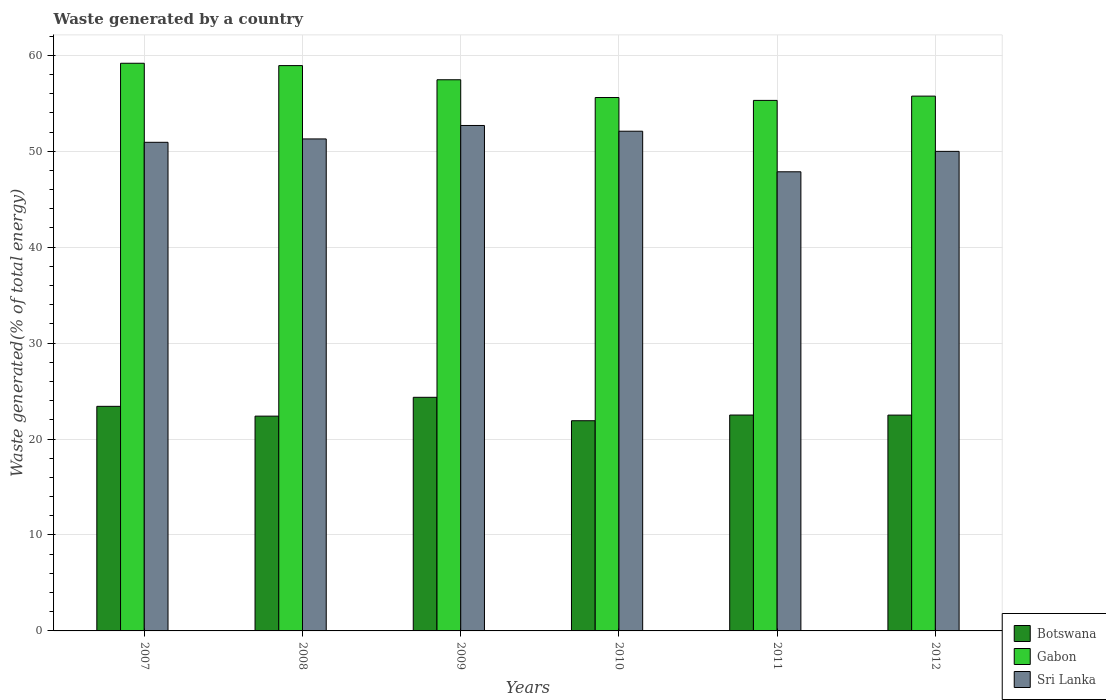How many different coloured bars are there?
Offer a terse response. 3. How many groups of bars are there?
Provide a short and direct response. 6. Are the number of bars per tick equal to the number of legend labels?
Offer a terse response. Yes. Are the number of bars on each tick of the X-axis equal?
Offer a very short reply. Yes. How many bars are there on the 4th tick from the left?
Offer a very short reply. 3. In how many cases, is the number of bars for a given year not equal to the number of legend labels?
Give a very brief answer. 0. What is the total waste generated in Sri Lanka in 2009?
Offer a very short reply. 52.68. Across all years, what is the maximum total waste generated in Gabon?
Provide a short and direct response. 59.17. Across all years, what is the minimum total waste generated in Sri Lanka?
Offer a very short reply. 47.86. In which year was the total waste generated in Sri Lanka maximum?
Provide a short and direct response. 2009. In which year was the total waste generated in Botswana minimum?
Your answer should be very brief. 2010. What is the total total waste generated in Botswana in the graph?
Provide a short and direct response. 137.05. What is the difference between the total waste generated in Botswana in 2009 and that in 2012?
Your response must be concise. 1.86. What is the difference between the total waste generated in Botswana in 2008 and the total waste generated in Sri Lanka in 2010?
Make the answer very short. -29.7. What is the average total waste generated in Gabon per year?
Make the answer very short. 57.03. In the year 2009, what is the difference between the total waste generated in Botswana and total waste generated in Gabon?
Offer a very short reply. -33.1. In how many years, is the total waste generated in Sri Lanka greater than 30 %?
Offer a terse response. 6. What is the ratio of the total waste generated in Botswana in 2008 to that in 2012?
Give a very brief answer. 1. Is the total waste generated in Sri Lanka in 2007 less than that in 2012?
Give a very brief answer. No. What is the difference between the highest and the second highest total waste generated in Botswana?
Your answer should be very brief. 0.94. What is the difference between the highest and the lowest total waste generated in Gabon?
Keep it short and to the point. 3.87. In how many years, is the total waste generated in Botswana greater than the average total waste generated in Botswana taken over all years?
Provide a short and direct response. 2. Is the sum of the total waste generated in Gabon in 2010 and 2012 greater than the maximum total waste generated in Sri Lanka across all years?
Give a very brief answer. Yes. What does the 1st bar from the left in 2011 represents?
Your response must be concise. Botswana. What does the 2nd bar from the right in 2012 represents?
Ensure brevity in your answer.  Gabon. Is it the case that in every year, the sum of the total waste generated in Gabon and total waste generated in Botswana is greater than the total waste generated in Sri Lanka?
Offer a terse response. Yes. How many bars are there?
Your answer should be compact. 18. Are all the bars in the graph horizontal?
Ensure brevity in your answer.  No. Does the graph contain any zero values?
Ensure brevity in your answer.  No. Does the graph contain grids?
Provide a succinct answer. Yes. How are the legend labels stacked?
Make the answer very short. Vertical. What is the title of the graph?
Your response must be concise. Waste generated by a country. What is the label or title of the Y-axis?
Your response must be concise. Waste generated(% of total energy). What is the Waste generated(% of total energy) of Botswana in 2007?
Make the answer very short. 23.41. What is the Waste generated(% of total energy) of Gabon in 2007?
Your answer should be compact. 59.17. What is the Waste generated(% of total energy) of Sri Lanka in 2007?
Your answer should be compact. 50.93. What is the Waste generated(% of total energy) in Botswana in 2008?
Provide a short and direct response. 22.39. What is the Waste generated(% of total energy) of Gabon in 2008?
Offer a very short reply. 58.93. What is the Waste generated(% of total energy) of Sri Lanka in 2008?
Give a very brief answer. 51.28. What is the Waste generated(% of total energy) in Botswana in 2009?
Offer a terse response. 24.35. What is the Waste generated(% of total energy) in Gabon in 2009?
Offer a terse response. 57.45. What is the Waste generated(% of total energy) in Sri Lanka in 2009?
Ensure brevity in your answer.  52.68. What is the Waste generated(% of total energy) of Botswana in 2010?
Give a very brief answer. 21.91. What is the Waste generated(% of total energy) in Gabon in 2010?
Provide a short and direct response. 55.6. What is the Waste generated(% of total energy) of Sri Lanka in 2010?
Your response must be concise. 52.09. What is the Waste generated(% of total energy) of Botswana in 2011?
Offer a terse response. 22.5. What is the Waste generated(% of total energy) in Gabon in 2011?
Offer a very short reply. 55.3. What is the Waste generated(% of total energy) of Sri Lanka in 2011?
Make the answer very short. 47.86. What is the Waste generated(% of total energy) in Botswana in 2012?
Ensure brevity in your answer.  22.5. What is the Waste generated(% of total energy) of Gabon in 2012?
Your response must be concise. 55.74. What is the Waste generated(% of total energy) in Sri Lanka in 2012?
Make the answer very short. 49.99. Across all years, what is the maximum Waste generated(% of total energy) in Botswana?
Keep it short and to the point. 24.35. Across all years, what is the maximum Waste generated(% of total energy) in Gabon?
Give a very brief answer. 59.17. Across all years, what is the maximum Waste generated(% of total energy) of Sri Lanka?
Your response must be concise. 52.68. Across all years, what is the minimum Waste generated(% of total energy) of Botswana?
Offer a very short reply. 21.91. Across all years, what is the minimum Waste generated(% of total energy) of Gabon?
Give a very brief answer. 55.3. Across all years, what is the minimum Waste generated(% of total energy) in Sri Lanka?
Keep it short and to the point. 47.86. What is the total Waste generated(% of total energy) of Botswana in the graph?
Provide a succinct answer. 137.05. What is the total Waste generated(% of total energy) in Gabon in the graph?
Provide a succinct answer. 342.18. What is the total Waste generated(% of total energy) of Sri Lanka in the graph?
Ensure brevity in your answer.  304.82. What is the difference between the Waste generated(% of total energy) in Botswana in 2007 and that in 2008?
Give a very brief answer. 1.02. What is the difference between the Waste generated(% of total energy) in Gabon in 2007 and that in 2008?
Your answer should be very brief. 0.24. What is the difference between the Waste generated(% of total energy) of Sri Lanka in 2007 and that in 2008?
Ensure brevity in your answer.  -0.35. What is the difference between the Waste generated(% of total energy) in Botswana in 2007 and that in 2009?
Offer a very short reply. -0.94. What is the difference between the Waste generated(% of total energy) of Gabon in 2007 and that in 2009?
Your response must be concise. 1.72. What is the difference between the Waste generated(% of total energy) of Sri Lanka in 2007 and that in 2009?
Provide a succinct answer. -1.75. What is the difference between the Waste generated(% of total energy) of Botswana in 2007 and that in 2010?
Provide a succinct answer. 1.5. What is the difference between the Waste generated(% of total energy) of Gabon in 2007 and that in 2010?
Ensure brevity in your answer.  3.57. What is the difference between the Waste generated(% of total energy) of Sri Lanka in 2007 and that in 2010?
Provide a succinct answer. -1.16. What is the difference between the Waste generated(% of total energy) of Botswana in 2007 and that in 2011?
Keep it short and to the point. 0.91. What is the difference between the Waste generated(% of total energy) of Gabon in 2007 and that in 2011?
Your answer should be compact. 3.87. What is the difference between the Waste generated(% of total energy) in Sri Lanka in 2007 and that in 2011?
Provide a short and direct response. 3.07. What is the difference between the Waste generated(% of total energy) of Botswana in 2007 and that in 2012?
Your answer should be compact. 0.91. What is the difference between the Waste generated(% of total energy) of Gabon in 2007 and that in 2012?
Provide a succinct answer. 3.43. What is the difference between the Waste generated(% of total energy) of Sri Lanka in 2007 and that in 2012?
Your response must be concise. 0.94. What is the difference between the Waste generated(% of total energy) of Botswana in 2008 and that in 2009?
Provide a short and direct response. -1.96. What is the difference between the Waste generated(% of total energy) in Gabon in 2008 and that in 2009?
Give a very brief answer. 1.48. What is the difference between the Waste generated(% of total energy) in Sri Lanka in 2008 and that in 2009?
Your response must be concise. -1.4. What is the difference between the Waste generated(% of total energy) of Botswana in 2008 and that in 2010?
Make the answer very short. 0.48. What is the difference between the Waste generated(% of total energy) of Gabon in 2008 and that in 2010?
Provide a short and direct response. 3.33. What is the difference between the Waste generated(% of total energy) in Sri Lanka in 2008 and that in 2010?
Your answer should be very brief. -0.8. What is the difference between the Waste generated(% of total energy) of Botswana in 2008 and that in 2011?
Give a very brief answer. -0.11. What is the difference between the Waste generated(% of total energy) of Gabon in 2008 and that in 2011?
Keep it short and to the point. 3.63. What is the difference between the Waste generated(% of total energy) in Sri Lanka in 2008 and that in 2011?
Your answer should be compact. 3.43. What is the difference between the Waste generated(% of total energy) of Botswana in 2008 and that in 2012?
Ensure brevity in your answer.  -0.11. What is the difference between the Waste generated(% of total energy) in Gabon in 2008 and that in 2012?
Provide a short and direct response. 3.18. What is the difference between the Waste generated(% of total energy) of Sri Lanka in 2008 and that in 2012?
Your answer should be compact. 1.3. What is the difference between the Waste generated(% of total energy) of Botswana in 2009 and that in 2010?
Your answer should be very brief. 2.44. What is the difference between the Waste generated(% of total energy) of Gabon in 2009 and that in 2010?
Make the answer very short. 1.85. What is the difference between the Waste generated(% of total energy) of Sri Lanka in 2009 and that in 2010?
Make the answer very short. 0.6. What is the difference between the Waste generated(% of total energy) in Botswana in 2009 and that in 2011?
Keep it short and to the point. 1.85. What is the difference between the Waste generated(% of total energy) of Gabon in 2009 and that in 2011?
Offer a very short reply. 2.15. What is the difference between the Waste generated(% of total energy) of Sri Lanka in 2009 and that in 2011?
Offer a terse response. 4.83. What is the difference between the Waste generated(% of total energy) of Botswana in 2009 and that in 2012?
Provide a short and direct response. 1.86. What is the difference between the Waste generated(% of total energy) in Gabon in 2009 and that in 2012?
Your answer should be very brief. 1.71. What is the difference between the Waste generated(% of total energy) of Sri Lanka in 2009 and that in 2012?
Provide a short and direct response. 2.7. What is the difference between the Waste generated(% of total energy) of Botswana in 2010 and that in 2011?
Ensure brevity in your answer.  -0.59. What is the difference between the Waste generated(% of total energy) of Gabon in 2010 and that in 2011?
Give a very brief answer. 0.3. What is the difference between the Waste generated(% of total energy) of Sri Lanka in 2010 and that in 2011?
Make the answer very short. 4.23. What is the difference between the Waste generated(% of total energy) of Botswana in 2010 and that in 2012?
Keep it short and to the point. -0.59. What is the difference between the Waste generated(% of total energy) in Gabon in 2010 and that in 2012?
Provide a short and direct response. -0.15. What is the difference between the Waste generated(% of total energy) of Sri Lanka in 2010 and that in 2012?
Your answer should be compact. 2.1. What is the difference between the Waste generated(% of total energy) of Botswana in 2011 and that in 2012?
Your response must be concise. 0.01. What is the difference between the Waste generated(% of total energy) in Gabon in 2011 and that in 2012?
Offer a very short reply. -0.45. What is the difference between the Waste generated(% of total energy) of Sri Lanka in 2011 and that in 2012?
Make the answer very short. -2.13. What is the difference between the Waste generated(% of total energy) of Botswana in 2007 and the Waste generated(% of total energy) of Gabon in 2008?
Your answer should be compact. -35.52. What is the difference between the Waste generated(% of total energy) of Botswana in 2007 and the Waste generated(% of total energy) of Sri Lanka in 2008?
Your answer should be compact. -27.87. What is the difference between the Waste generated(% of total energy) in Gabon in 2007 and the Waste generated(% of total energy) in Sri Lanka in 2008?
Ensure brevity in your answer.  7.89. What is the difference between the Waste generated(% of total energy) in Botswana in 2007 and the Waste generated(% of total energy) in Gabon in 2009?
Offer a very short reply. -34.04. What is the difference between the Waste generated(% of total energy) of Botswana in 2007 and the Waste generated(% of total energy) of Sri Lanka in 2009?
Give a very brief answer. -29.28. What is the difference between the Waste generated(% of total energy) in Gabon in 2007 and the Waste generated(% of total energy) in Sri Lanka in 2009?
Keep it short and to the point. 6.48. What is the difference between the Waste generated(% of total energy) in Botswana in 2007 and the Waste generated(% of total energy) in Gabon in 2010?
Your answer should be very brief. -32.19. What is the difference between the Waste generated(% of total energy) of Botswana in 2007 and the Waste generated(% of total energy) of Sri Lanka in 2010?
Provide a short and direct response. -28.68. What is the difference between the Waste generated(% of total energy) of Gabon in 2007 and the Waste generated(% of total energy) of Sri Lanka in 2010?
Your answer should be very brief. 7.08. What is the difference between the Waste generated(% of total energy) in Botswana in 2007 and the Waste generated(% of total energy) in Gabon in 2011?
Offer a terse response. -31.89. What is the difference between the Waste generated(% of total energy) of Botswana in 2007 and the Waste generated(% of total energy) of Sri Lanka in 2011?
Provide a succinct answer. -24.45. What is the difference between the Waste generated(% of total energy) in Gabon in 2007 and the Waste generated(% of total energy) in Sri Lanka in 2011?
Your response must be concise. 11.31. What is the difference between the Waste generated(% of total energy) of Botswana in 2007 and the Waste generated(% of total energy) of Gabon in 2012?
Give a very brief answer. -32.33. What is the difference between the Waste generated(% of total energy) in Botswana in 2007 and the Waste generated(% of total energy) in Sri Lanka in 2012?
Your answer should be very brief. -26.58. What is the difference between the Waste generated(% of total energy) in Gabon in 2007 and the Waste generated(% of total energy) in Sri Lanka in 2012?
Your answer should be compact. 9.18. What is the difference between the Waste generated(% of total energy) in Botswana in 2008 and the Waste generated(% of total energy) in Gabon in 2009?
Your response must be concise. -35.06. What is the difference between the Waste generated(% of total energy) in Botswana in 2008 and the Waste generated(% of total energy) in Sri Lanka in 2009?
Provide a short and direct response. -30.3. What is the difference between the Waste generated(% of total energy) in Gabon in 2008 and the Waste generated(% of total energy) in Sri Lanka in 2009?
Your answer should be very brief. 6.24. What is the difference between the Waste generated(% of total energy) of Botswana in 2008 and the Waste generated(% of total energy) of Gabon in 2010?
Give a very brief answer. -33.21. What is the difference between the Waste generated(% of total energy) in Botswana in 2008 and the Waste generated(% of total energy) in Sri Lanka in 2010?
Make the answer very short. -29.7. What is the difference between the Waste generated(% of total energy) in Gabon in 2008 and the Waste generated(% of total energy) in Sri Lanka in 2010?
Provide a short and direct response. 6.84. What is the difference between the Waste generated(% of total energy) in Botswana in 2008 and the Waste generated(% of total energy) in Gabon in 2011?
Your answer should be very brief. -32.91. What is the difference between the Waste generated(% of total energy) of Botswana in 2008 and the Waste generated(% of total energy) of Sri Lanka in 2011?
Your response must be concise. -25.47. What is the difference between the Waste generated(% of total energy) in Gabon in 2008 and the Waste generated(% of total energy) in Sri Lanka in 2011?
Ensure brevity in your answer.  11.07. What is the difference between the Waste generated(% of total energy) in Botswana in 2008 and the Waste generated(% of total energy) in Gabon in 2012?
Give a very brief answer. -33.36. What is the difference between the Waste generated(% of total energy) of Botswana in 2008 and the Waste generated(% of total energy) of Sri Lanka in 2012?
Provide a short and direct response. -27.6. What is the difference between the Waste generated(% of total energy) of Gabon in 2008 and the Waste generated(% of total energy) of Sri Lanka in 2012?
Offer a very short reply. 8.94. What is the difference between the Waste generated(% of total energy) of Botswana in 2009 and the Waste generated(% of total energy) of Gabon in 2010?
Ensure brevity in your answer.  -31.25. What is the difference between the Waste generated(% of total energy) in Botswana in 2009 and the Waste generated(% of total energy) in Sri Lanka in 2010?
Your answer should be very brief. -27.74. What is the difference between the Waste generated(% of total energy) in Gabon in 2009 and the Waste generated(% of total energy) in Sri Lanka in 2010?
Your answer should be very brief. 5.36. What is the difference between the Waste generated(% of total energy) in Botswana in 2009 and the Waste generated(% of total energy) in Gabon in 2011?
Provide a short and direct response. -30.95. What is the difference between the Waste generated(% of total energy) of Botswana in 2009 and the Waste generated(% of total energy) of Sri Lanka in 2011?
Ensure brevity in your answer.  -23.51. What is the difference between the Waste generated(% of total energy) in Gabon in 2009 and the Waste generated(% of total energy) in Sri Lanka in 2011?
Keep it short and to the point. 9.59. What is the difference between the Waste generated(% of total energy) of Botswana in 2009 and the Waste generated(% of total energy) of Gabon in 2012?
Offer a very short reply. -31.39. What is the difference between the Waste generated(% of total energy) in Botswana in 2009 and the Waste generated(% of total energy) in Sri Lanka in 2012?
Give a very brief answer. -25.63. What is the difference between the Waste generated(% of total energy) in Gabon in 2009 and the Waste generated(% of total energy) in Sri Lanka in 2012?
Provide a succinct answer. 7.46. What is the difference between the Waste generated(% of total energy) in Botswana in 2010 and the Waste generated(% of total energy) in Gabon in 2011?
Ensure brevity in your answer.  -33.39. What is the difference between the Waste generated(% of total energy) of Botswana in 2010 and the Waste generated(% of total energy) of Sri Lanka in 2011?
Offer a terse response. -25.95. What is the difference between the Waste generated(% of total energy) of Gabon in 2010 and the Waste generated(% of total energy) of Sri Lanka in 2011?
Your answer should be very brief. 7.74. What is the difference between the Waste generated(% of total energy) in Botswana in 2010 and the Waste generated(% of total energy) in Gabon in 2012?
Ensure brevity in your answer.  -33.83. What is the difference between the Waste generated(% of total energy) of Botswana in 2010 and the Waste generated(% of total energy) of Sri Lanka in 2012?
Offer a terse response. -28.08. What is the difference between the Waste generated(% of total energy) of Gabon in 2010 and the Waste generated(% of total energy) of Sri Lanka in 2012?
Your response must be concise. 5.61. What is the difference between the Waste generated(% of total energy) of Botswana in 2011 and the Waste generated(% of total energy) of Gabon in 2012?
Keep it short and to the point. -33.24. What is the difference between the Waste generated(% of total energy) in Botswana in 2011 and the Waste generated(% of total energy) in Sri Lanka in 2012?
Provide a succinct answer. -27.48. What is the difference between the Waste generated(% of total energy) of Gabon in 2011 and the Waste generated(% of total energy) of Sri Lanka in 2012?
Your response must be concise. 5.31. What is the average Waste generated(% of total energy) in Botswana per year?
Your response must be concise. 22.84. What is the average Waste generated(% of total energy) in Gabon per year?
Your answer should be very brief. 57.03. What is the average Waste generated(% of total energy) of Sri Lanka per year?
Ensure brevity in your answer.  50.8. In the year 2007, what is the difference between the Waste generated(% of total energy) in Botswana and Waste generated(% of total energy) in Gabon?
Offer a very short reply. -35.76. In the year 2007, what is the difference between the Waste generated(% of total energy) of Botswana and Waste generated(% of total energy) of Sri Lanka?
Make the answer very short. -27.52. In the year 2007, what is the difference between the Waste generated(% of total energy) of Gabon and Waste generated(% of total energy) of Sri Lanka?
Provide a short and direct response. 8.24. In the year 2008, what is the difference between the Waste generated(% of total energy) in Botswana and Waste generated(% of total energy) in Gabon?
Your answer should be very brief. -36.54. In the year 2008, what is the difference between the Waste generated(% of total energy) in Botswana and Waste generated(% of total energy) in Sri Lanka?
Make the answer very short. -28.89. In the year 2008, what is the difference between the Waste generated(% of total energy) in Gabon and Waste generated(% of total energy) in Sri Lanka?
Keep it short and to the point. 7.64. In the year 2009, what is the difference between the Waste generated(% of total energy) of Botswana and Waste generated(% of total energy) of Gabon?
Provide a succinct answer. -33.1. In the year 2009, what is the difference between the Waste generated(% of total energy) in Botswana and Waste generated(% of total energy) in Sri Lanka?
Provide a short and direct response. -28.33. In the year 2009, what is the difference between the Waste generated(% of total energy) of Gabon and Waste generated(% of total energy) of Sri Lanka?
Offer a very short reply. 4.76. In the year 2010, what is the difference between the Waste generated(% of total energy) of Botswana and Waste generated(% of total energy) of Gabon?
Ensure brevity in your answer.  -33.69. In the year 2010, what is the difference between the Waste generated(% of total energy) in Botswana and Waste generated(% of total energy) in Sri Lanka?
Your response must be concise. -30.18. In the year 2010, what is the difference between the Waste generated(% of total energy) of Gabon and Waste generated(% of total energy) of Sri Lanka?
Your response must be concise. 3.51. In the year 2011, what is the difference between the Waste generated(% of total energy) in Botswana and Waste generated(% of total energy) in Gabon?
Offer a terse response. -32.8. In the year 2011, what is the difference between the Waste generated(% of total energy) in Botswana and Waste generated(% of total energy) in Sri Lanka?
Your answer should be very brief. -25.36. In the year 2011, what is the difference between the Waste generated(% of total energy) in Gabon and Waste generated(% of total energy) in Sri Lanka?
Your response must be concise. 7.44. In the year 2012, what is the difference between the Waste generated(% of total energy) of Botswana and Waste generated(% of total energy) of Gabon?
Make the answer very short. -33.25. In the year 2012, what is the difference between the Waste generated(% of total energy) of Botswana and Waste generated(% of total energy) of Sri Lanka?
Keep it short and to the point. -27.49. In the year 2012, what is the difference between the Waste generated(% of total energy) of Gabon and Waste generated(% of total energy) of Sri Lanka?
Offer a terse response. 5.76. What is the ratio of the Waste generated(% of total energy) of Botswana in 2007 to that in 2008?
Provide a short and direct response. 1.05. What is the ratio of the Waste generated(% of total energy) in Gabon in 2007 to that in 2008?
Ensure brevity in your answer.  1. What is the ratio of the Waste generated(% of total energy) of Sri Lanka in 2007 to that in 2008?
Your answer should be compact. 0.99. What is the ratio of the Waste generated(% of total energy) of Botswana in 2007 to that in 2009?
Offer a terse response. 0.96. What is the ratio of the Waste generated(% of total energy) of Gabon in 2007 to that in 2009?
Your answer should be very brief. 1.03. What is the ratio of the Waste generated(% of total energy) of Sri Lanka in 2007 to that in 2009?
Offer a terse response. 0.97. What is the ratio of the Waste generated(% of total energy) of Botswana in 2007 to that in 2010?
Keep it short and to the point. 1.07. What is the ratio of the Waste generated(% of total energy) of Gabon in 2007 to that in 2010?
Ensure brevity in your answer.  1.06. What is the ratio of the Waste generated(% of total energy) in Sri Lanka in 2007 to that in 2010?
Your answer should be compact. 0.98. What is the ratio of the Waste generated(% of total energy) of Botswana in 2007 to that in 2011?
Give a very brief answer. 1.04. What is the ratio of the Waste generated(% of total energy) in Gabon in 2007 to that in 2011?
Make the answer very short. 1.07. What is the ratio of the Waste generated(% of total energy) of Sri Lanka in 2007 to that in 2011?
Your answer should be very brief. 1.06. What is the ratio of the Waste generated(% of total energy) in Botswana in 2007 to that in 2012?
Offer a very short reply. 1.04. What is the ratio of the Waste generated(% of total energy) of Gabon in 2007 to that in 2012?
Offer a terse response. 1.06. What is the ratio of the Waste generated(% of total energy) in Sri Lanka in 2007 to that in 2012?
Provide a short and direct response. 1.02. What is the ratio of the Waste generated(% of total energy) of Botswana in 2008 to that in 2009?
Offer a terse response. 0.92. What is the ratio of the Waste generated(% of total energy) in Gabon in 2008 to that in 2009?
Your answer should be very brief. 1.03. What is the ratio of the Waste generated(% of total energy) of Sri Lanka in 2008 to that in 2009?
Your answer should be compact. 0.97. What is the ratio of the Waste generated(% of total energy) in Botswana in 2008 to that in 2010?
Provide a succinct answer. 1.02. What is the ratio of the Waste generated(% of total energy) of Gabon in 2008 to that in 2010?
Your answer should be compact. 1.06. What is the ratio of the Waste generated(% of total energy) of Sri Lanka in 2008 to that in 2010?
Make the answer very short. 0.98. What is the ratio of the Waste generated(% of total energy) in Gabon in 2008 to that in 2011?
Keep it short and to the point. 1.07. What is the ratio of the Waste generated(% of total energy) of Sri Lanka in 2008 to that in 2011?
Provide a short and direct response. 1.07. What is the ratio of the Waste generated(% of total energy) in Botswana in 2008 to that in 2012?
Keep it short and to the point. 1. What is the ratio of the Waste generated(% of total energy) of Gabon in 2008 to that in 2012?
Offer a terse response. 1.06. What is the ratio of the Waste generated(% of total energy) in Sri Lanka in 2008 to that in 2012?
Ensure brevity in your answer.  1.03. What is the ratio of the Waste generated(% of total energy) of Botswana in 2009 to that in 2010?
Offer a very short reply. 1.11. What is the ratio of the Waste generated(% of total energy) of Sri Lanka in 2009 to that in 2010?
Your answer should be compact. 1.01. What is the ratio of the Waste generated(% of total energy) of Botswana in 2009 to that in 2011?
Offer a very short reply. 1.08. What is the ratio of the Waste generated(% of total energy) of Gabon in 2009 to that in 2011?
Provide a succinct answer. 1.04. What is the ratio of the Waste generated(% of total energy) in Sri Lanka in 2009 to that in 2011?
Give a very brief answer. 1.1. What is the ratio of the Waste generated(% of total energy) of Botswana in 2009 to that in 2012?
Offer a very short reply. 1.08. What is the ratio of the Waste generated(% of total energy) of Gabon in 2009 to that in 2012?
Offer a very short reply. 1.03. What is the ratio of the Waste generated(% of total energy) of Sri Lanka in 2009 to that in 2012?
Make the answer very short. 1.05. What is the ratio of the Waste generated(% of total energy) in Botswana in 2010 to that in 2011?
Offer a very short reply. 0.97. What is the ratio of the Waste generated(% of total energy) of Gabon in 2010 to that in 2011?
Offer a very short reply. 1.01. What is the ratio of the Waste generated(% of total energy) in Sri Lanka in 2010 to that in 2011?
Ensure brevity in your answer.  1.09. What is the ratio of the Waste generated(% of total energy) of Sri Lanka in 2010 to that in 2012?
Provide a short and direct response. 1.04. What is the ratio of the Waste generated(% of total energy) in Gabon in 2011 to that in 2012?
Your answer should be compact. 0.99. What is the ratio of the Waste generated(% of total energy) of Sri Lanka in 2011 to that in 2012?
Offer a very short reply. 0.96. What is the difference between the highest and the second highest Waste generated(% of total energy) of Botswana?
Your answer should be compact. 0.94. What is the difference between the highest and the second highest Waste generated(% of total energy) in Gabon?
Provide a short and direct response. 0.24. What is the difference between the highest and the second highest Waste generated(% of total energy) in Sri Lanka?
Your response must be concise. 0.6. What is the difference between the highest and the lowest Waste generated(% of total energy) of Botswana?
Keep it short and to the point. 2.44. What is the difference between the highest and the lowest Waste generated(% of total energy) in Gabon?
Make the answer very short. 3.87. What is the difference between the highest and the lowest Waste generated(% of total energy) of Sri Lanka?
Your answer should be very brief. 4.83. 